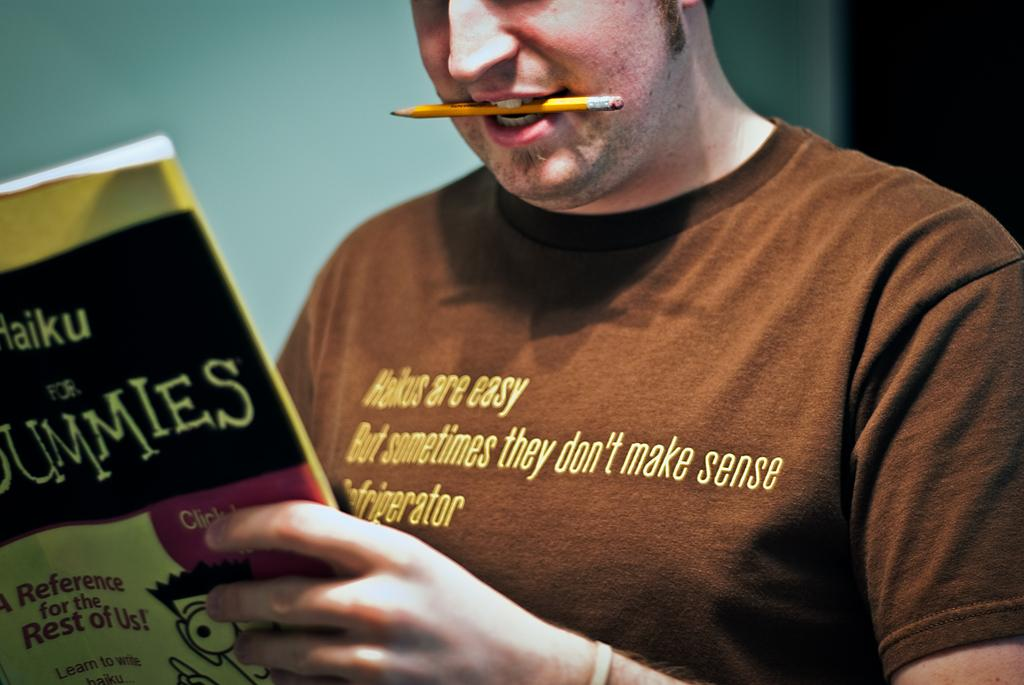<image>
Present a compact description of the photo's key features. Man with a pencil in his mouse reading Haiku for Dummies. 